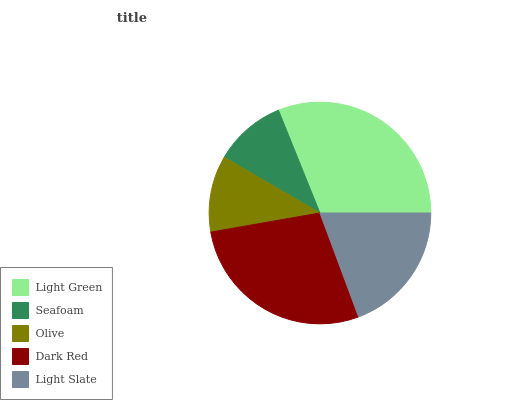Is Seafoam the minimum?
Answer yes or no. Yes. Is Light Green the maximum?
Answer yes or no. Yes. Is Olive the minimum?
Answer yes or no. No. Is Olive the maximum?
Answer yes or no. No. Is Olive greater than Seafoam?
Answer yes or no. Yes. Is Seafoam less than Olive?
Answer yes or no. Yes. Is Seafoam greater than Olive?
Answer yes or no. No. Is Olive less than Seafoam?
Answer yes or no. No. Is Light Slate the high median?
Answer yes or no. Yes. Is Light Slate the low median?
Answer yes or no. Yes. Is Olive the high median?
Answer yes or no. No. Is Seafoam the low median?
Answer yes or no. No. 